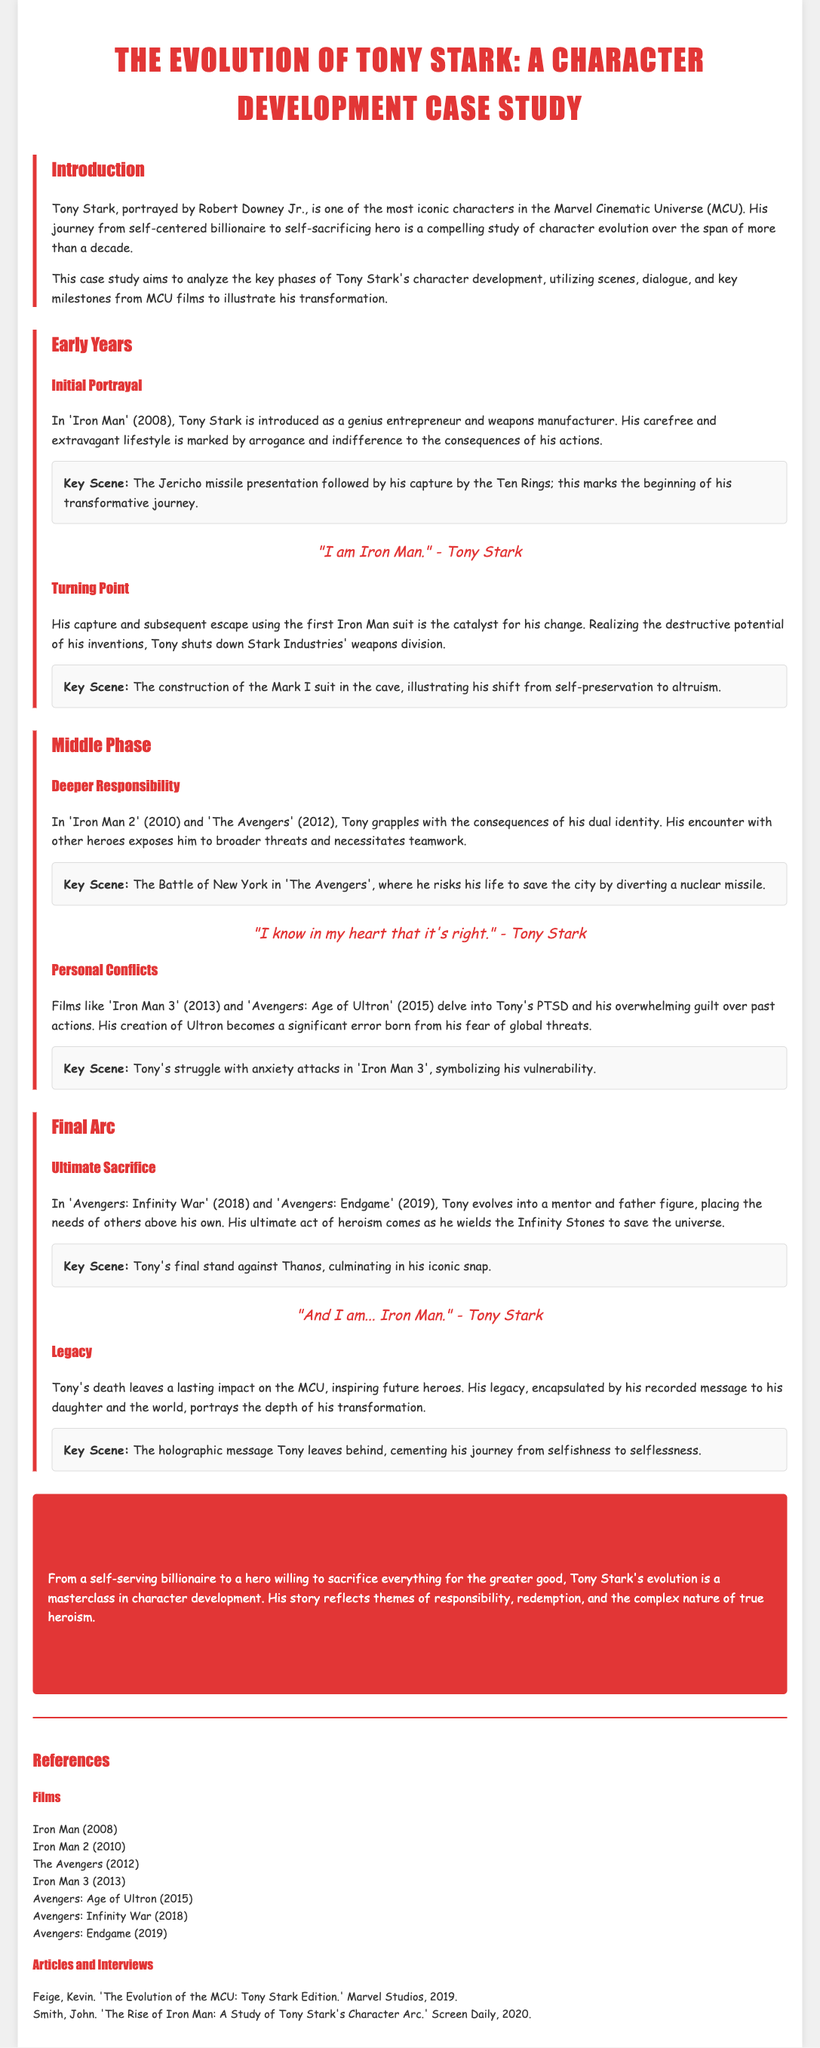What is the title of the case study? The title of the case study is prominently displayed at the top of the document, indicating the focus on Tony Stark's character development.
Answer: The Evolution of Tony Stark: A Character Development Case Study In which film does Tony Stark first appear? The document mentions the film that introduces Tony Stark as a character, which is crucial for understanding his origins.
Answer: Iron Man What year was 'Iron Man' released? The release date of 'Iron Man' is specified in the document, providing context for the character's initial portrayal.
Answer: 2008 What motivates Tony Stark to shut down Stark Industries' weapons division? The document states that a significant realization during his capture leads to a pivotal change in Tony Stark's perspective on his inventions.
Answer: Destructive potential of his inventions What key event does Tony Stark risk his life during in 'The Avengers'? This event is a significant moment that highlights Tony's emerging heroism and willingness to sacrifice for the greater good.
Answer: The Battle of New York How does Tony Stark's character address personal conflicts in 'Iron Man 3'? The document explains Tony's struggle with emotional challenges, indicating a deeper internal conflict that affects his character arc.
Answer: PTSD What phrase encapsulates Tony Stark's legacy at the end of the document? The document concludes by summarizing the essence of Tony Stark's journey and the impact it leaves on future heroes.
Answer: "Part of the journey is the end." What does the holographic message symbolize in Tony Stark's legacy? The document ties the holographic message to the theme of transformation and service to others, showcasing a significant aspect of his character evolution.
Answer: Journey from selfishness to selflessness 